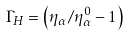Convert formula to latex. <formula><loc_0><loc_0><loc_500><loc_500>\Gamma _ { H } = \left ( { \eta _ { \alpha } / \eta ^ { 0 } _ { \alpha } } - 1 \right )</formula> 